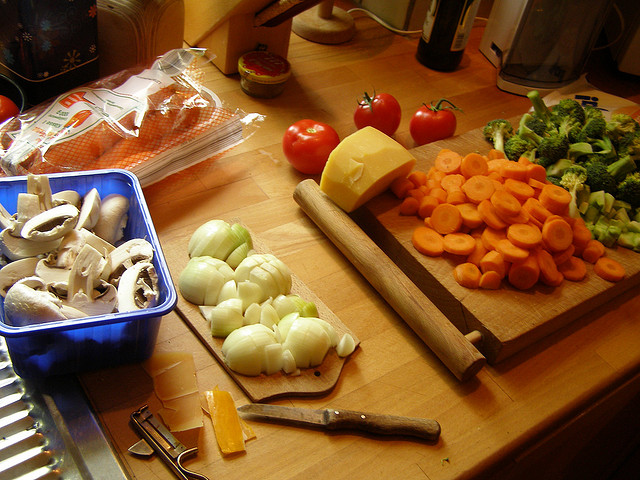Can you identify all the items on the counter? Certainly! There are mushrooms, a whole onion and chopped onions, sliced carrots, broccoli florets, two whole tomatoes, a block of cheese, a rolling pin, and what appears to be a pack of spaghetti. Additionally, there's a kitchen knife and some other items in the background that are less distinguishable. Is there anything in the image that suggests the type of cuisine being prepared? The presence of tomatoes, onions, and spaghetti suggests that the dish could be Italian-inspired, potentially a pasta dish with a vegetable sauce or a tomato-based dish. 